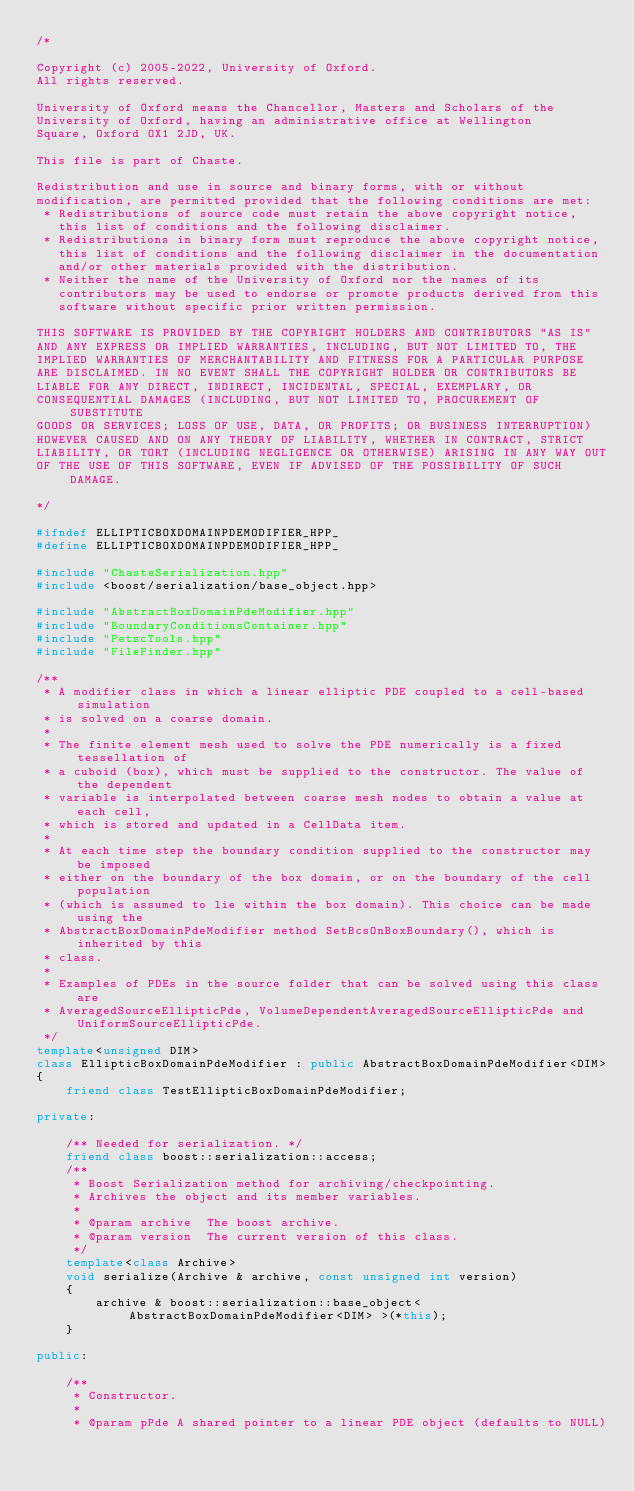<code> <loc_0><loc_0><loc_500><loc_500><_C++_>/*

Copyright (c) 2005-2022, University of Oxford.
All rights reserved.

University of Oxford means the Chancellor, Masters and Scholars of the
University of Oxford, having an administrative office at Wellington
Square, Oxford OX1 2JD, UK.

This file is part of Chaste.

Redistribution and use in source and binary forms, with or without
modification, are permitted provided that the following conditions are met:
 * Redistributions of source code must retain the above copyright notice,
   this list of conditions and the following disclaimer.
 * Redistributions in binary form must reproduce the above copyright notice,
   this list of conditions and the following disclaimer in the documentation
   and/or other materials provided with the distribution.
 * Neither the name of the University of Oxford nor the names of its
   contributors may be used to endorse or promote products derived from this
   software without specific prior written permission.

THIS SOFTWARE IS PROVIDED BY THE COPYRIGHT HOLDERS AND CONTRIBUTORS "AS IS"
AND ANY EXPRESS OR IMPLIED WARRANTIES, INCLUDING, BUT NOT LIMITED TO, THE
IMPLIED WARRANTIES OF MERCHANTABILITY AND FITNESS FOR A PARTICULAR PURPOSE
ARE DISCLAIMED. IN NO EVENT SHALL THE COPYRIGHT HOLDER OR CONTRIBUTORS BE
LIABLE FOR ANY DIRECT, INDIRECT, INCIDENTAL, SPECIAL, EXEMPLARY, OR
CONSEQUENTIAL DAMAGES (INCLUDING, BUT NOT LIMITED TO, PROCUREMENT OF SUBSTITUTE
GOODS OR SERVICES; LOSS OF USE, DATA, OR PROFITS; OR BUSINESS INTERRUPTION)
HOWEVER CAUSED AND ON ANY THEORY OF LIABILITY, WHETHER IN CONTRACT, STRICT
LIABILITY, OR TORT (INCLUDING NEGLIGENCE OR OTHERWISE) ARISING IN ANY WAY OUT
OF THE USE OF THIS SOFTWARE, EVEN IF ADVISED OF THE POSSIBILITY OF SUCH DAMAGE.

*/

#ifndef ELLIPTICBOXDOMAINPDEMODIFIER_HPP_
#define ELLIPTICBOXDOMAINPDEMODIFIER_HPP_

#include "ChasteSerialization.hpp"
#include <boost/serialization/base_object.hpp>

#include "AbstractBoxDomainPdeModifier.hpp"
#include "BoundaryConditionsContainer.hpp"
#include "PetscTools.hpp"
#include "FileFinder.hpp"

/**
 * A modifier class in which a linear elliptic PDE coupled to a cell-based simulation
 * is solved on a coarse domain.
 *
 * The finite element mesh used to solve the PDE numerically is a fixed tessellation of
 * a cuboid (box), which must be supplied to the constructor. The value of the dependent
 * variable is interpolated between coarse mesh nodes to obtain a value at each cell,
 * which is stored and updated in a CellData item.
 *
 * At each time step the boundary condition supplied to the constructor may be imposed
 * either on the boundary of the box domain, or on the boundary of the cell population
 * (which is assumed to lie within the box domain). This choice can be made using the
 * AbstractBoxDomainPdeModifier method SetBcsOnBoxBoundary(), which is inherited by this
 * class.
 *
 * Examples of PDEs in the source folder that can be solved using this class are
 * AveragedSourceEllipticPde, VolumeDependentAveragedSourceEllipticPde and UniformSourceEllipticPde.
 */
template<unsigned DIM>
class EllipticBoxDomainPdeModifier : public AbstractBoxDomainPdeModifier<DIM>
{
    friend class TestEllipticBoxDomainPdeModifier;

private:

    /** Needed for serialization. */
    friend class boost::serialization::access;
    /**
     * Boost Serialization method for archiving/checkpointing.
     * Archives the object and its member variables.
     *
     * @param archive  The boost archive.
     * @param version  The current version of this class.
     */
    template<class Archive>
    void serialize(Archive & archive, const unsigned int version)
    {
        archive & boost::serialization::base_object<AbstractBoxDomainPdeModifier<DIM> >(*this);
    }

public:

    /**
     * Constructor.
     *
     * @param pPde A shared pointer to a linear PDE object (defaults to NULL)</code> 